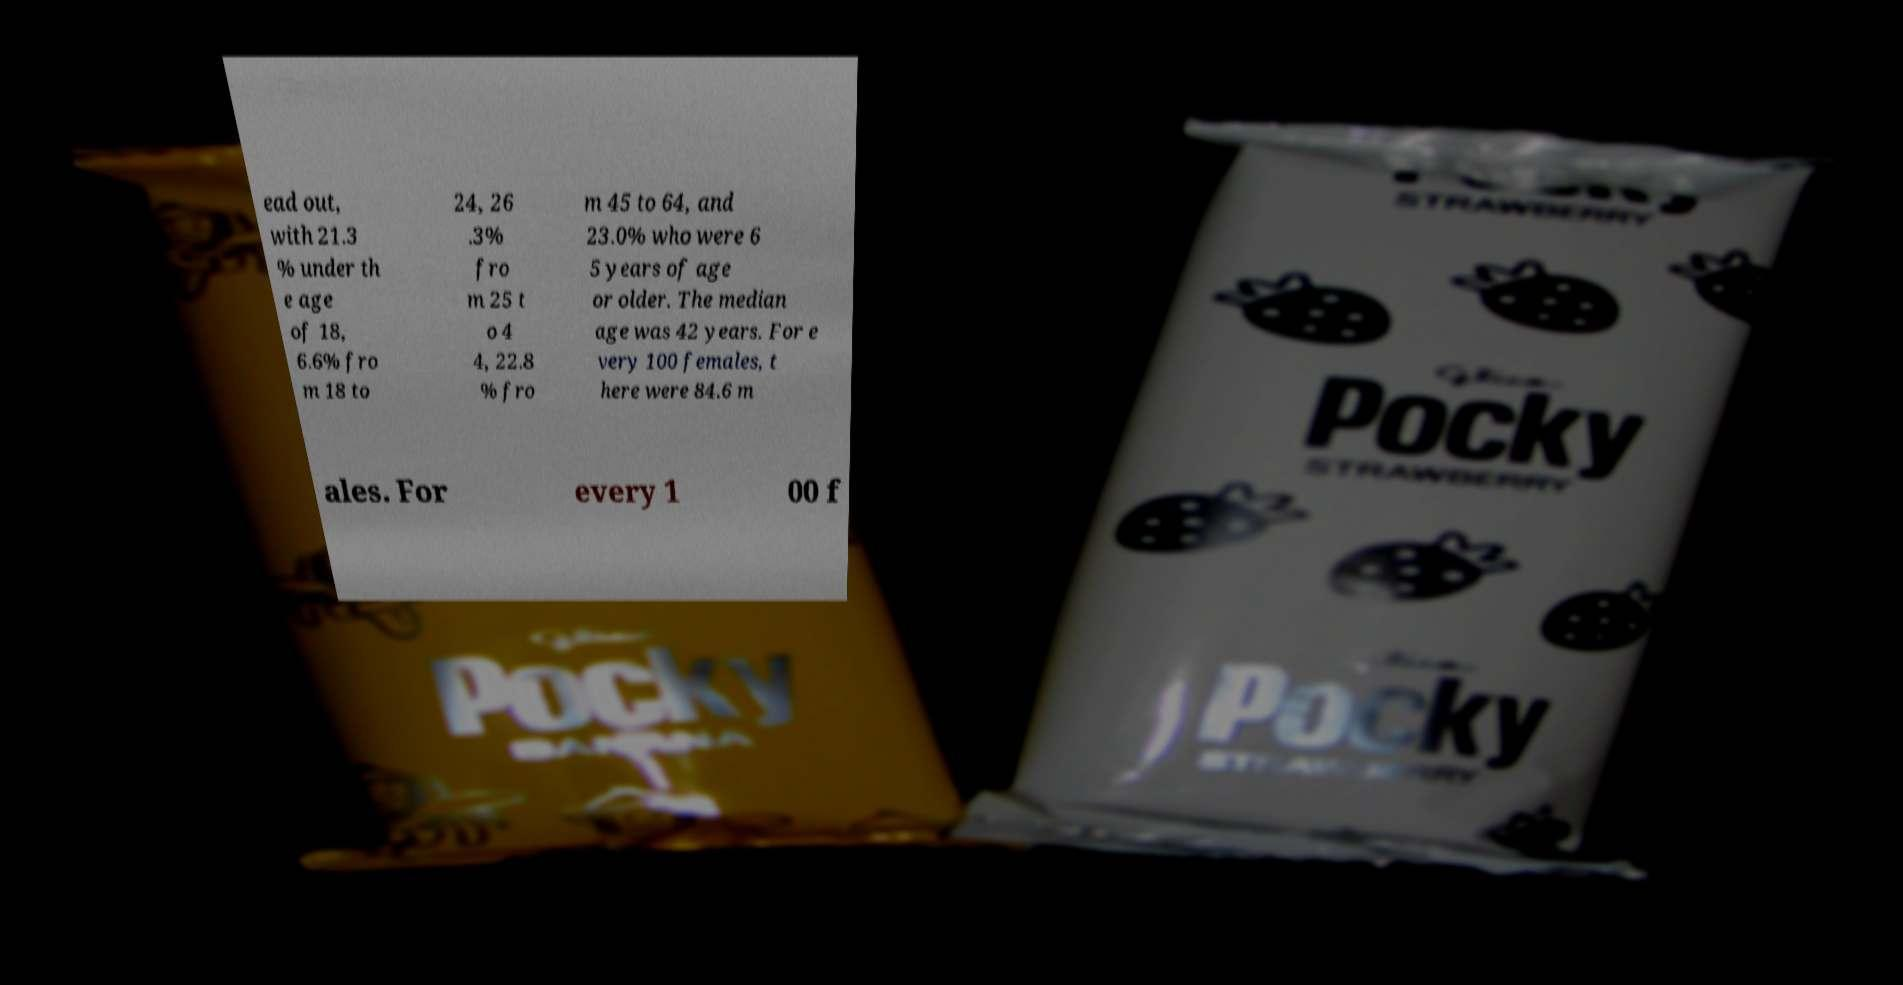There's text embedded in this image that I need extracted. Can you transcribe it verbatim? ead out, with 21.3 % under th e age of 18, 6.6% fro m 18 to 24, 26 .3% fro m 25 t o 4 4, 22.8 % fro m 45 to 64, and 23.0% who were 6 5 years of age or older. The median age was 42 years. For e very 100 females, t here were 84.6 m ales. For every 1 00 f 